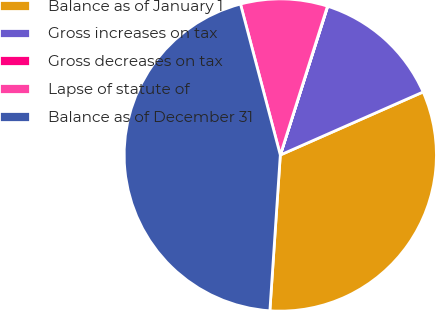Convert chart to OTSL. <chart><loc_0><loc_0><loc_500><loc_500><pie_chart><fcel>Balance as of January 1<fcel>Gross increases on tax<fcel>Gross decreases on tax<fcel>Lapse of statute of<fcel>Balance as of December 31<nl><fcel>32.68%<fcel>13.47%<fcel>0.03%<fcel>8.99%<fcel>44.83%<nl></chart> 